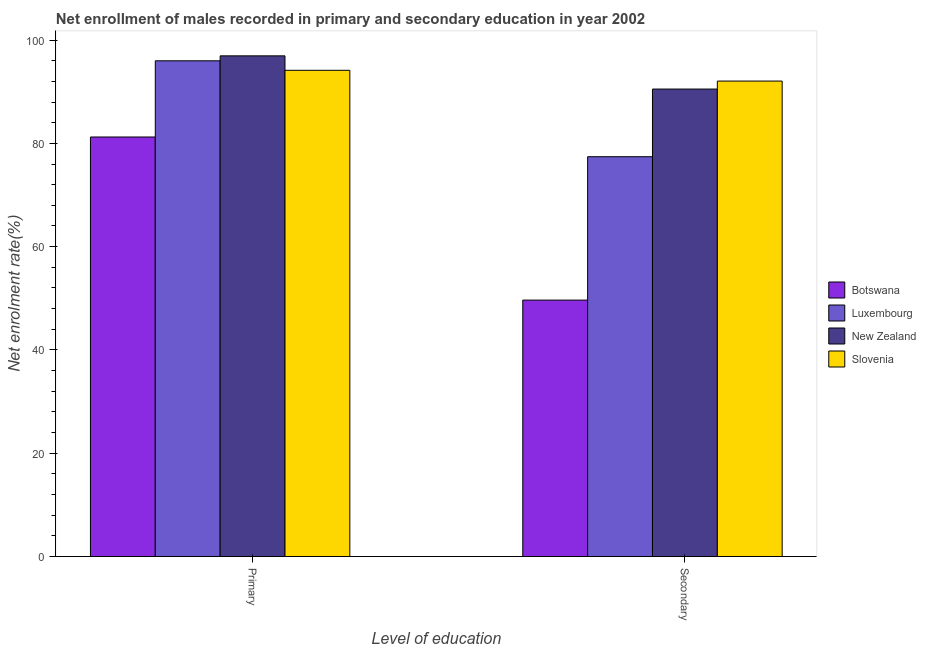Are the number of bars per tick equal to the number of legend labels?
Keep it short and to the point. Yes. Are the number of bars on each tick of the X-axis equal?
Your answer should be very brief. Yes. How many bars are there on the 2nd tick from the left?
Provide a short and direct response. 4. What is the label of the 1st group of bars from the left?
Provide a short and direct response. Primary. What is the enrollment rate in primary education in Botswana?
Your answer should be compact. 81.23. Across all countries, what is the maximum enrollment rate in secondary education?
Keep it short and to the point. 92.06. Across all countries, what is the minimum enrollment rate in secondary education?
Make the answer very short. 49.65. In which country was the enrollment rate in secondary education maximum?
Your response must be concise. Slovenia. In which country was the enrollment rate in secondary education minimum?
Offer a very short reply. Botswana. What is the total enrollment rate in secondary education in the graph?
Offer a very short reply. 309.64. What is the difference between the enrollment rate in primary education in Luxembourg and that in New Zealand?
Keep it short and to the point. -0.96. What is the difference between the enrollment rate in secondary education in Botswana and the enrollment rate in primary education in New Zealand?
Provide a succinct answer. -47.29. What is the average enrollment rate in secondary education per country?
Provide a succinct answer. 77.41. What is the difference between the enrollment rate in primary education and enrollment rate in secondary education in Luxembourg?
Provide a succinct answer. 18.57. What is the ratio of the enrollment rate in primary education in Luxembourg to that in Botswana?
Ensure brevity in your answer.  1.18. Is the enrollment rate in secondary education in Slovenia less than that in Botswana?
Give a very brief answer. No. What does the 4th bar from the left in Primary represents?
Your response must be concise. Slovenia. What does the 1st bar from the right in Primary represents?
Offer a very short reply. Slovenia. Are all the bars in the graph horizontal?
Ensure brevity in your answer.  No. Does the graph contain grids?
Offer a very short reply. No. Where does the legend appear in the graph?
Your answer should be compact. Center right. How many legend labels are there?
Offer a terse response. 4. How are the legend labels stacked?
Offer a terse response. Vertical. What is the title of the graph?
Offer a very short reply. Net enrollment of males recorded in primary and secondary education in year 2002. Does "Somalia" appear as one of the legend labels in the graph?
Your answer should be compact. No. What is the label or title of the X-axis?
Your response must be concise. Level of education. What is the label or title of the Y-axis?
Your answer should be very brief. Net enrolment rate(%). What is the Net enrolment rate(%) in Botswana in Primary?
Offer a terse response. 81.23. What is the Net enrolment rate(%) in Luxembourg in Primary?
Provide a short and direct response. 95.99. What is the Net enrolment rate(%) in New Zealand in Primary?
Make the answer very short. 96.94. What is the Net enrolment rate(%) of Slovenia in Primary?
Your response must be concise. 94.14. What is the Net enrolment rate(%) of Botswana in Secondary?
Your response must be concise. 49.65. What is the Net enrolment rate(%) in Luxembourg in Secondary?
Keep it short and to the point. 77.42. What is the Net enrolment rate(%) in New Zealand in Secondary?
Make the answer very short. 90.51. What is the Net enrolment rate(%) in Slovenia in Secondary?
Offer a terse response. 92.06. Across all Level of education, what is the maximum Net enrolment rate(%) of Botswana?
Offer a very short reply. 81.23. Across all Level of education, what is the maximum Net enrolment rate(%) of Luxembourg?
Provide a succinct answer. 95.99. Across all Level of education, what is the maximum Net enrolment rate(%) in New Zealand?
Make the answer very short. 96.94. Across all Level of education, what is the maximum Net enrolment rate(%) of Slovenia?
Offer a very short reply. 94.14. Across all Level of education, what is the minimum Net enrolment rate(%) of Botswana?
Offer a terse response. 49.65. Across all Level of education, what is the minimum Net enrolment rate(%) in Luxembourg?
Make the answer very short. 77.42. Across all Level of education, what is the minimum Net enrolment rate(%) of New Zealand?
Your answer should be very brief. 90.51. Across all Level of education, what is the minimum Net enrolment rate(%) in Slovenia?
Your response must be concise. 92.06. What is the total Net enrolment rate(%) of Botswana in the graph?
Offer a terse response. 130.88. What is the total Net enrolment rate(%) in Luxembourg in the graph?
Make the answer very short. 173.4. What is the total Net enrolment rate(%) in New Zealand in the graph?
Your answer should be very brief. 187.46. What is the total Net enrolment rate(%) in Slovenia in the graph?
Offer a very short reply. 186.21. What is the difference between the Net enrolment rate(%) of Botswana in Primary and that in Secondary?
Your answer should be compact. 31.58. What is the difference between the Net enrolment rate(%) in Luxembourg in Primary and that in Secondary?
Make the answer very short. 18.57. What is the difference between the Net enrolment rate(%) of New Zealand in Primary and that in Secondary?
Provide a succinct answer. 6.43. What is the difference between the Net enrolment rate(%) of Slovenia in Primary and that in Secondary?
Ensure brevity in your answer.  2.08. What is the difference between the Net enrolment rate(%) of Botswana in Primary and the Net enrolment rate(%) of Luxembourg in Secondary?
Your response must be concise. 3.82. What is the difference between the Net enrolment rate(%) in Botswana in Primary and the Net enrolment rate(%) in New Zealand in Secondary?
Provide a short and direct response. -9.28. What is the difference between the Net enrolment rate(%) in Botswana in Primary and the Net enrolment rate(%) in Slovenia in Secondary?
Your answer should be very brief. -10.83. What is the difference between the Net enrolment rate(%) of Luxembourg in Primary and the Net enrolment rate(%) of New Zealand in Secondary?
Give a very brief answer. 5.47. What is the difference between the Net enrolment rate(%) of Luxembourg in Primary and the Net enrolment rate(%) of Slovenia in Secondary?
Make the answer very short. 3.92. What is the difference between the Net enrolment rate(%) in New Zealand in Primary and the Net enrolment rate(%) in Slovenia in Secondary?
Offer a very short reply. 4.88. What is the average Net enrolment rate(%) of Botswana per Level of education?
Offer a terse response. 65.44. What is the average Net enrolment rate(%) in Luxembourg per Level of education?
Your answer should be very brief. 86.7. What is the average Net enrolment rate(%) in New Zealand per Level of education?
Give a very brief answer. 93.73. What is the average Net enrolment rate(%) of Slovenia per Level of education?
Your response must be concise. 93.1. What is the difference between the Net enrolment rate(%) of Botswana and Net enrolment rate(%) of Luxembourg in Primary?
Offer a very short reply. -14.75. What is the difference between the Net enrolment rate(%) of Botswana and Net enrolment rate(%) of New Zealand in Primary?
Your response must be concise. -15.71. What is the difference between the Net enrolment rate(%) in Botswana and Net enrolment rate(%) in Slovenia in Primary?
Offer a very short reply. -12.91. What is the difference between the Net enrolment rate(%) in Luxembourg and Net enrolment rate(%) in New Zealand in Primary?
Keep it short and to the point. -0.96. What is the difference between the Net enrolment rate(%) of Luxembourg and Net enrolment rate(%) of Slovenia in Primary?
Your answer should be very brief. 1.84. What is the difference between the Net enrolment rate(%) of New Zealand and Net enrolment rate(%) of Slovenia in Primary?
Provide a succinct answer. 2.8. What is the difference between the Net enrolment rate(%) in Botswana and Net enrolment rate(%) in Luxembourg in Secondary?
Keep it short and to the point. -27.76. What is the difference between the Net enrolment rate(%) of Botswana and Net enrolment rate(%) of New Zealand in Secondary?
Make the answer very short. -40.86. What is the difference between the Net enrolment rate(%) in Botswana and Net enrolment rate(%) in Slovenia in Secondary?
Provide a short and direct response. -42.41. What is the difference between the Net enrolment rate(%) in Luxembourg and Net enrolment rate(%) in New Zealand in Secondary?
Provide a short and direct response. -13.1. What is the difference between the Net enrolment rate(%) in Luxembourg and Net enrolment rate(%) in Slovenia in Secondary?
Provide a short and direct response. -14.65. What is the difference between the Net enrolment rate(%) of New Zealand and Net enrolment rate(%) of Slovenia in Secondary?
Make the answer very short. -1.55. What is the ratio of the Net enrolment rate(%) of Botswana in Primary to that in Secondary?
Give a very brief answer. 1.64. What is the ratio of the Net enrolment rate(%) of Luxembourg in Primary to that in Secondary?
Your response must be concise. 1.24. What is the ratio of the Net enrolment rate(%) in New Zealand in Primary to that in Secondary?
Provide a short and direct response. 1.07. What is the ratio of the Net enrolment rate(%) of Slovenia in Primary to that in Secondary?
Keep it short and to the point. 1.02. What is the difference between the highest and the second highest Net enrolment rate(%) in Botswana?
Offer a very short reply. 31.58. What is the difference between the highest and the second highest Net enrolment rate(%) of Luxembourg?
Offer a very short reply. 18.57. What is the difference between the highest and the second highest Net enrolment rate(%) in New Zealand?
Make the answer very short. 6.43. What is the difference between the highest and the second highest Net enrolment rate(%) of Slovenia?
Provide a short and direct response. 2.08. What is the difference between the highest and the lowest Net enrolment rate(%) in Botswana?
Your answer should be very brief. 31.58. What is the difference between the highest and the lowest Net enrolment rate(%) in Luxembourg?
Make the answer very short. 18.57. What is the difference between the highest and the lowest Net enrolment rate(%) in New Zealand?
Offer a very short reply. 6.43. What is the difference between the highest and the lowest Net enrolment rate(%) in Slovenia?
Offer a very short reply. 2.08. 